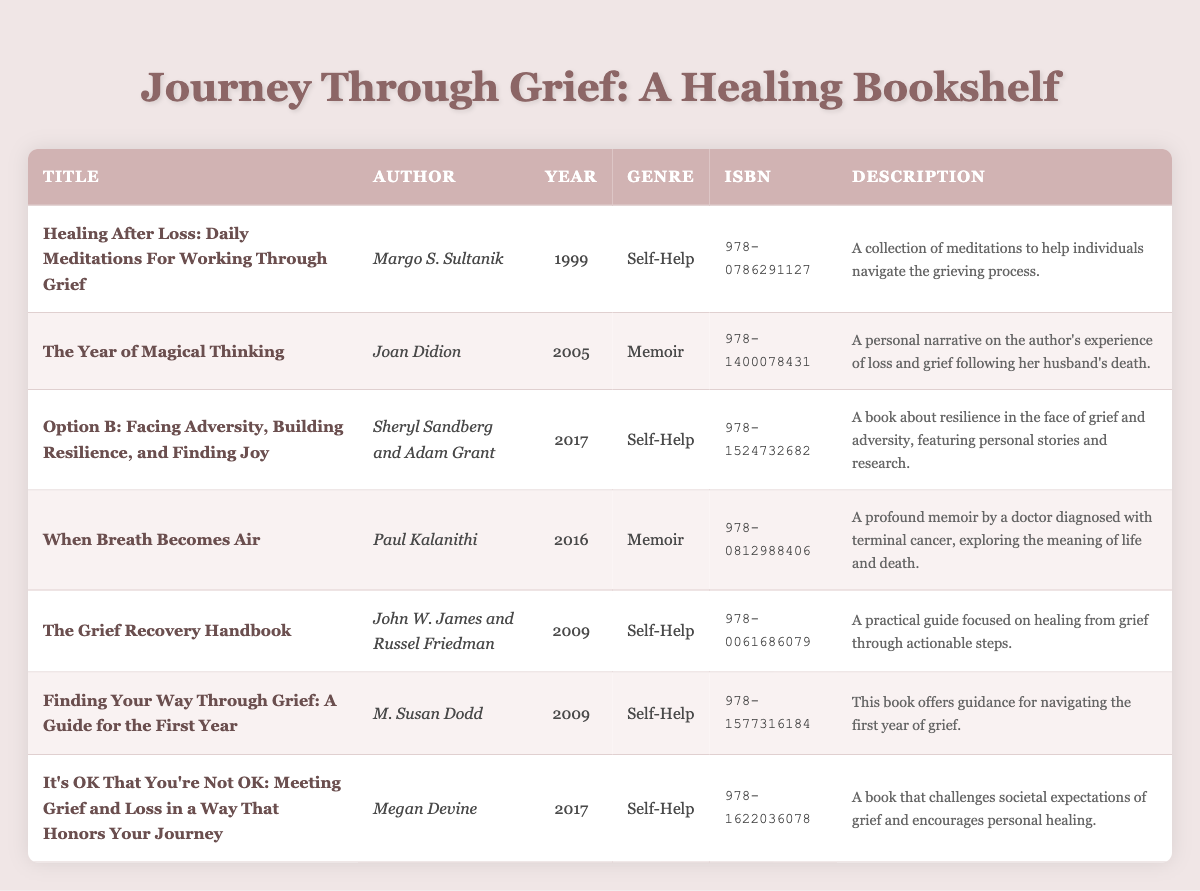What is the title of the book by Joan Didion? The table lists Joan Didion as the author of "The Year of Magical Thinking", so this is the title associated with her name.
Answer: The Year of Magical Thinking Which book has the ISBN 978-1524732682? By referring to the table, we can find that the book with the ISBN 978-1524732682 is "Option B: Facing Adversity, Building Resilience, and Finding Joy".
Answer: Option B: Facing Adversity, Building Resilience, and Finding Joy How many books in the table were published after 2010? The books published after 2010 are "Option B: Facing Adversity, Building Resilience, and Finding Joy" (2017), "When Breath Becomes Air" (2016), and "It's OK That You're Not OK" (2017), which totals three books.
Answer: 3 Is "Finding Your Way Through Grief: A Guide for the First Year" a self-help book? The genre listed for "Finding Your Way Through Grief: A Guide for the First Year" is self-help in the table. Therefore, it is indeed a self-help book.
Answer: Yes What average publication year for the books in the self-help genre? The self-help books are "Healing After Loss" (1999), "Option B" (2017), "The Grief Recovery Handbook" (2009), "Finding Your Way Through Grief" (2009), and "It's OK That You're Not OK" (2017). The average can be calculated as (1999 + 2017 + 2009 + 2009 + 2017) / 5 = 2012.2, rounded to 2012.
Answer: 2012 Which author wrote the most recent book in the table? By comparing the publication years, "It's OK That You're Not OK" by Megan Devine published in 2017 is the most recent book on the list.
Answer: Megan Devine Are there any memoirs listed in the table? There are two memoirs in the table: "The Year of Magical Thinking" by Joan Didion and "When Breath Becomes Air" by Paul Kalanithi. Therefore, the answer is yes.
Answer: Yes What is the shortest publication span between two books in the table? The table shows two books published in 2009: "The Grief Recovery Handbook" and "Finding Your Way Through Grief"; both were released in the same year, resulting in a span of 0 years.
Answer: 0 years 